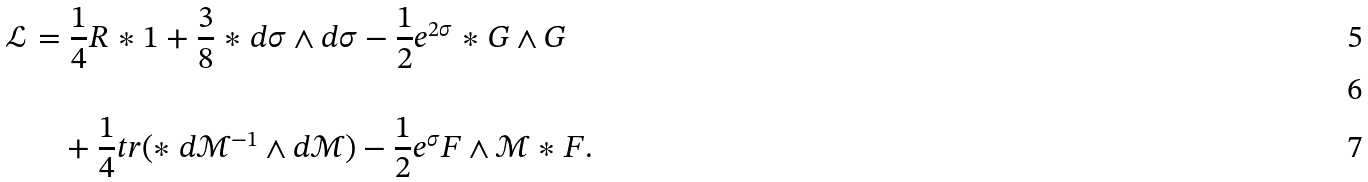<formula> <loc_0><loc_0><loc_500><loc_500>\mathcal { L } & = \frac { 1 } { 4 } R \ast 1 + \frac { 3 } { 8 } \ast d \sigma \wedge d \sigma - \frac { 1 } { 2 } e ^ { 2 \sigma } \ast G \wedge G \\ \\ & \quad + \frac { 1 } { 4 } t r ( \ast d \mathcal { M } ^ { - 1 } \wedge d \mathcal { M } ) - \frac { 1 } { 2 } e ^ { \sigma } F \wedge \mathcal { M } \ast F .</formula> 